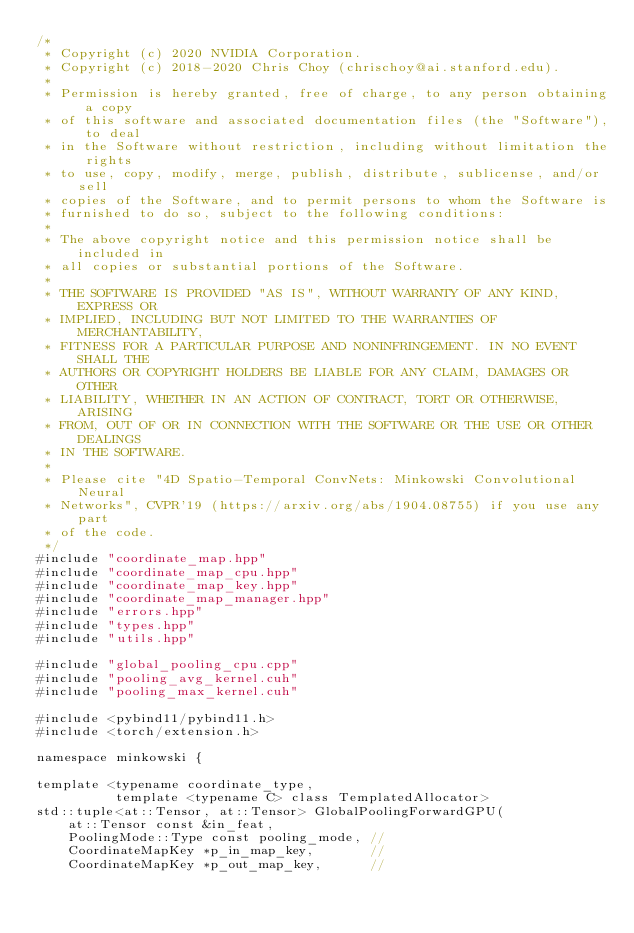Convert code to text. <code><loc_0><loc_0><loc_500><loc_500><_Cuda_>/*
 * Copyright (c) 2020 NVIDIA Corporation.
 * Copyright (c) 2018-2020 Chris Choy (chrischoy@ai.stanford.edu).
 *
 * Permission is hereby granted, free of charge, to any person obtaining a copy
 * of this software and associated documentation files (the "Software"), to deal
 * in the Software without restriction, including without limitation the rights
 * to use, copy, modify, merge, publish, distribute, sublicense, and/or sell
 * copies of the Software, and to permit persons to whom the Software is
 * furnished to do so, subject to the following conditions:
 *
 * The above copyright notice and this permission notice shall be included in
 * all copies or substantial portions of the Software.
 *
 * THE SOFTWARE IS PROVIDED "AS IS", WITHOUT WARRANTY OF ANY KIND, EXPRESS OR
 * IMPLIED, INCLUDING BUT NOT LIMITED TO THE WARRANTIES OF MERCHANTABILITY,
 * FITNESS FOR A PARTICULAR PURPOSE AND NONINFRINGEMENT. IN NO EVENT SHALL THE
 * AUTHORS OR COPYRIGHT HOLDERS BE LIABLE FOR ANY CLAIM, DAMAGES OR OTHER
 * LIABILITY, WHETHER IN AN ACTION OF CONTRACT, TORT OR OTHERWISE, ARISING
 * FROM, OUT OF OR IN CONNECTION WITH THE SOFTWARE OR THE USE OR OTHER DEALINGS
 * IN THE SOFTWARE.
 *
 * Please cite "4D Spatio-Temporal ConvNets: Minkowski Convolutional Neural
 * Networks", CVPR'19 (https://arxiv.org/abs/1904.08755) if you use any part
 * of the code.
 */
#include "coordinate_map.hpp"
#include "coordinate_map_cpu.hpp"
#include "coordinate_map_key.hpp"
#include "coordinate_map_manager.hpp"
#include "errors.hpp"
#include "types.hpp"
#include "utils.hpp"

#include "global_pooling_cpu.cpp"
#include "pooling_avg_kernel.cuh"
#include "pooling_max_kernel.cuh"

#include <pybind11/pybind11.h>
#include <torch/extension.h>

namespace minkowski {

template <typename coordinate_type,
          template <typename C> class TemplatedAllocator>
std::tuple<at::Tensor, at::Tensor> GlobalPoolingForwardGPU(
    at::Tensor const &in_feat,
    PoolingMode::Type const pooling_mode, //
    CoordinateMapKey *p_in_map_key,       //
    CoordinateMapKey *p_out_map_key,      //</code> 